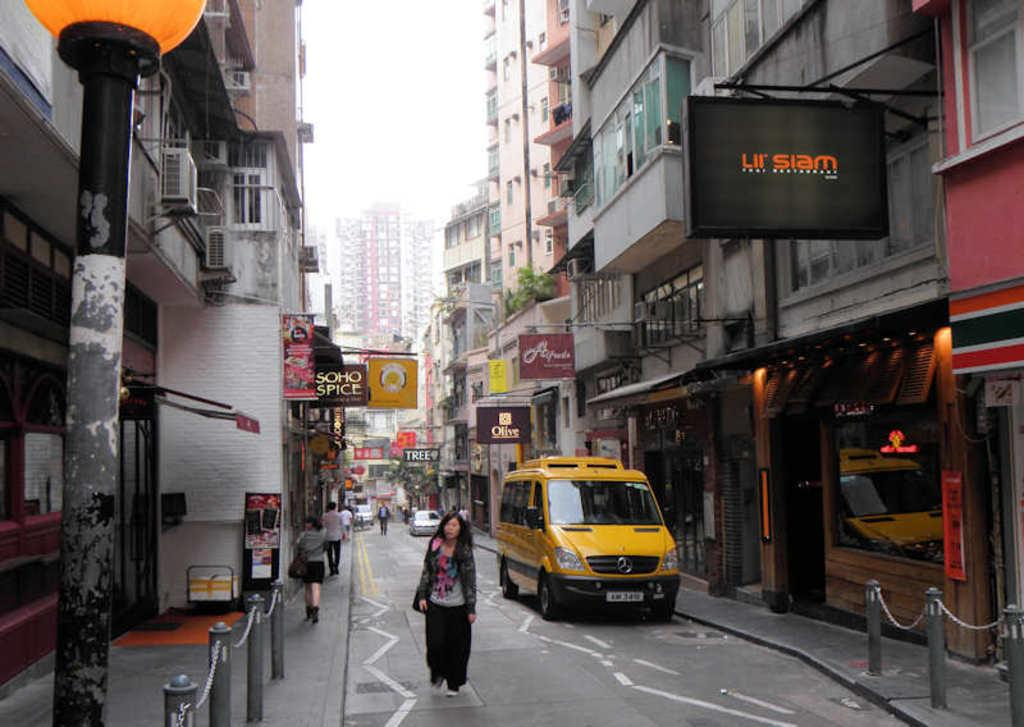<image>
Offer a succinct explanation of the picture presented. A narrow street with a business establishment called lil siam has a sign hanging outside. 